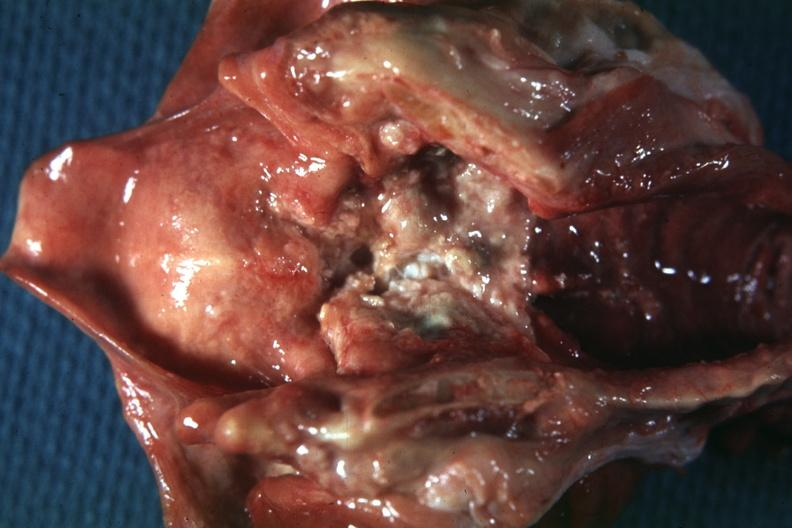where is this?
Answer the question using a single word or phrase. Oral 